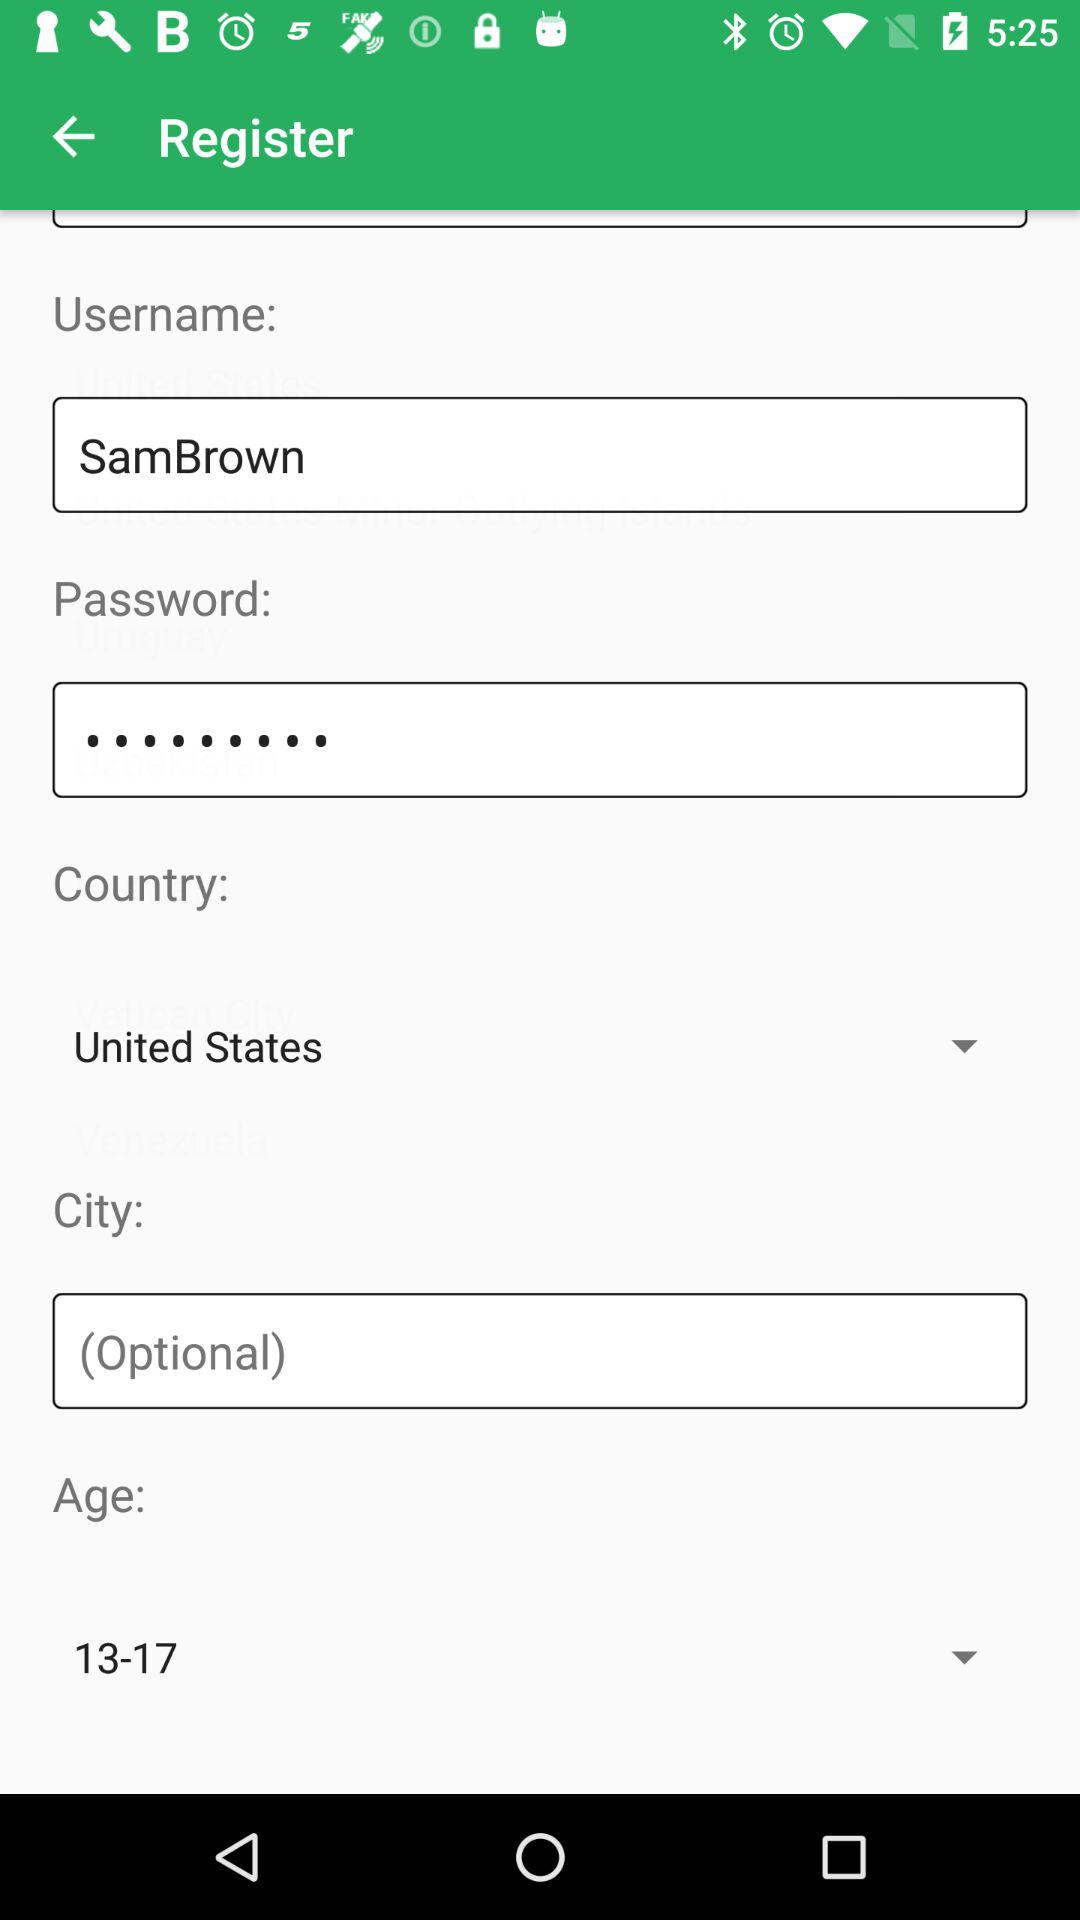Which age group is selected? The selected age group is from 13 to 17. 